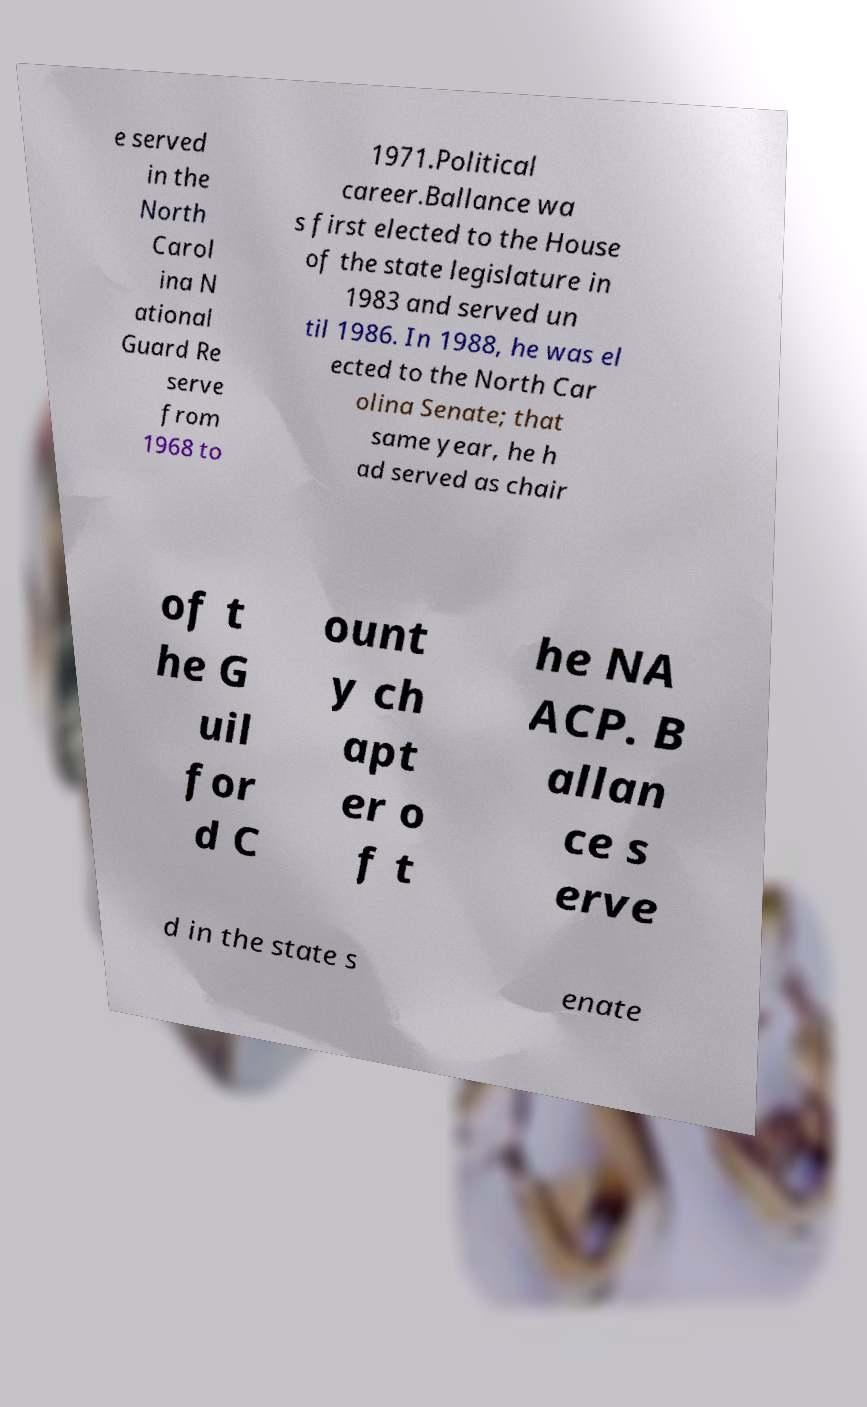There's text embedded in this image that I need extracted. Can you transcribe it verbatim? e served in the North Carol ina N ational Guard Re serve from 1968 to 1971.Political career.Ballance wa s first elected to the House of the state legislature in 1983 and served un til 1986. In 1988, he was el ected to the North Car olina Senate; that same year, he h ad served as chair of t he G uil for d C ount y ch apt er o f t he NA ACP. B allan ce s erve d in the state s enate 